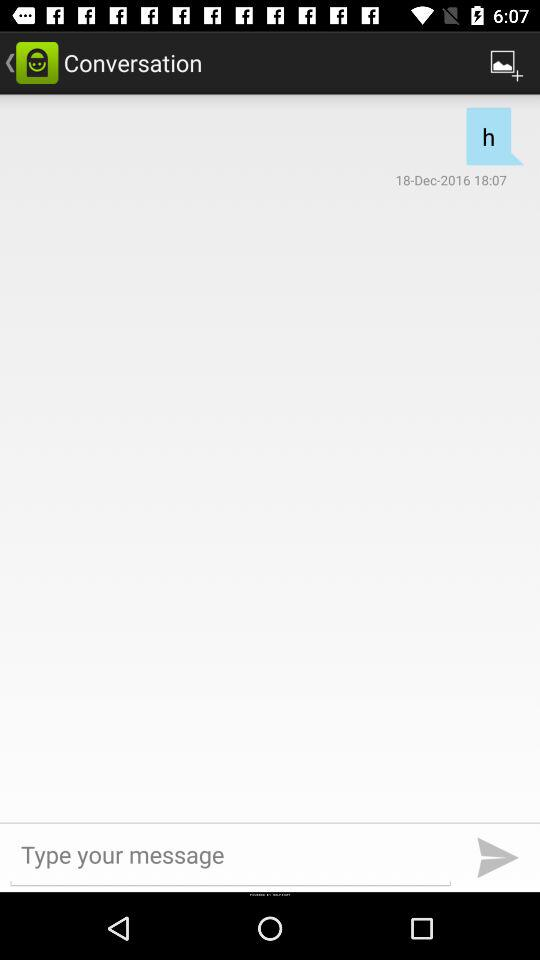Who sent the message?
When the provided information is insufficient, respond with <no answer>. <no answer> 